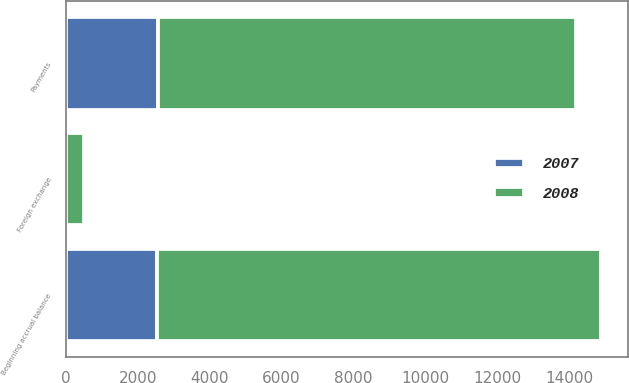Convert chart to OTSL. <chart><loc_0><loc_0><loc_500><loc_500><stacked_bar_chart><ecel><fcel>Beginning accrual balance<fcel>Payments<fcel>Foreign exchange<nl><fcel>2007<fcel>2538<fcel>2556<fcel>18<nl><fcel>2008<fcel>12363<fcel>11652<fcel>482<nl></chart> 